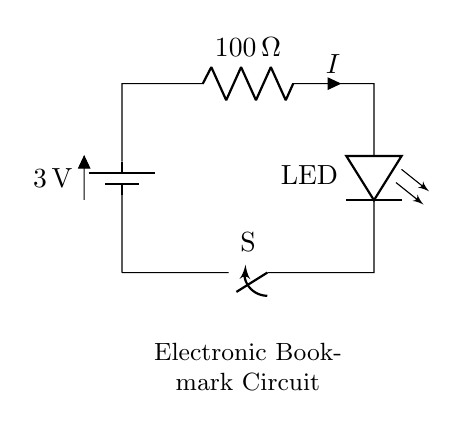What is the type of the power source in this circuit? The power source is a battery, indicated by the symbol in the circuit diagram. The label shows it provides a voltage of 3 volts.
Answer: battery What is the resistance value in this circuit? The circuit includes a resistor, clearly labeled with a value of 100 ohms next to its symbol.
Answer: 100 ohms What is the component that emits light in this circuit? The component is labeled as an LED, which stands for light-emitting diode, shown in the diagram as the light source.
Answer: LED What will happen if the switch is open? If the switch is open, the circuit is incomplete, meaning the flow of current will stop, and the LED will not light up.
Answer: LED off How does the current flow in this circuit when the switch is closed? When the switch is closed, current flows from the battery, through the resistor and the LED, creating a complete loop. This allows the LED to light up due to the current passing through it.
Answer: current flows What is the purpose of the switch in this circuit? The switch controls the flow of current; when closed, it completes the circuit, allowing the LED to illuminate, and when open, it breaks the circuit, turning off the LED.
Answer: control current How would increasing the resistance affect the LED brightness? Increasing the resistance would reduce the current flowing through the LED according to Ohm's law, causing the LED to dim, since LED brightness is dependent on the current passing through it.
Answer: LED will dim 